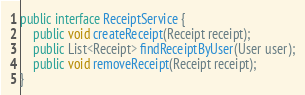<code> <loc_0><loc_0><loc_500><loc_500><_Java_>public interface ReceiptService {
	public void createReceipt(Receipt receipt);
	public List<Receipt> findReceiptByUser(User user);
	public void removeReceipt(Receipt receipt);
}
</code> 